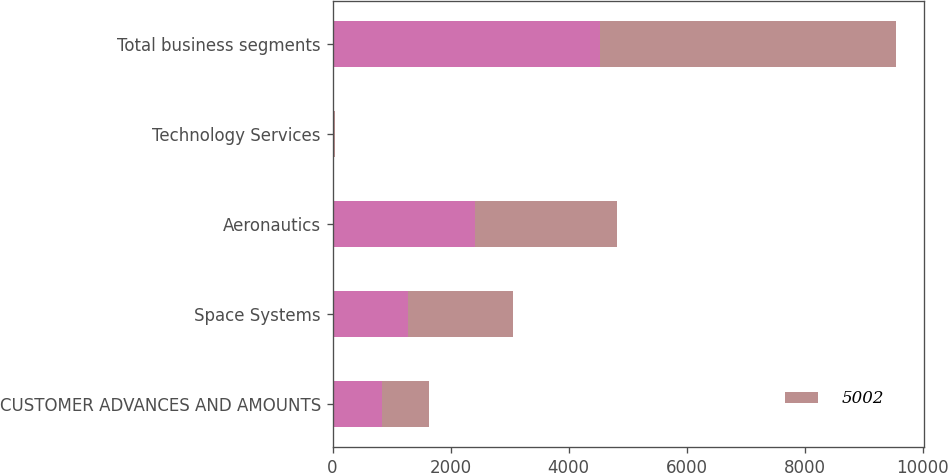Convert chart. <chart><loc_0><loc_0><loc_500><loc_500><stacked_bar_chart><ecel><fcel>CUSTOMER ADVANCES AND AMOUNTS<fcel>Space Systems<fcel>Aeronautics<fcel>Technology Services<fcel>Total business segments<nl><fcel>nan<fcel>836<fcel>1275<fcel>2408<fcel>19<fcel>4538<nl><fcel>5002<fcel>797<fcel>1784<fcel>2406<fcel>15<fcel>5002<nl></chart> 